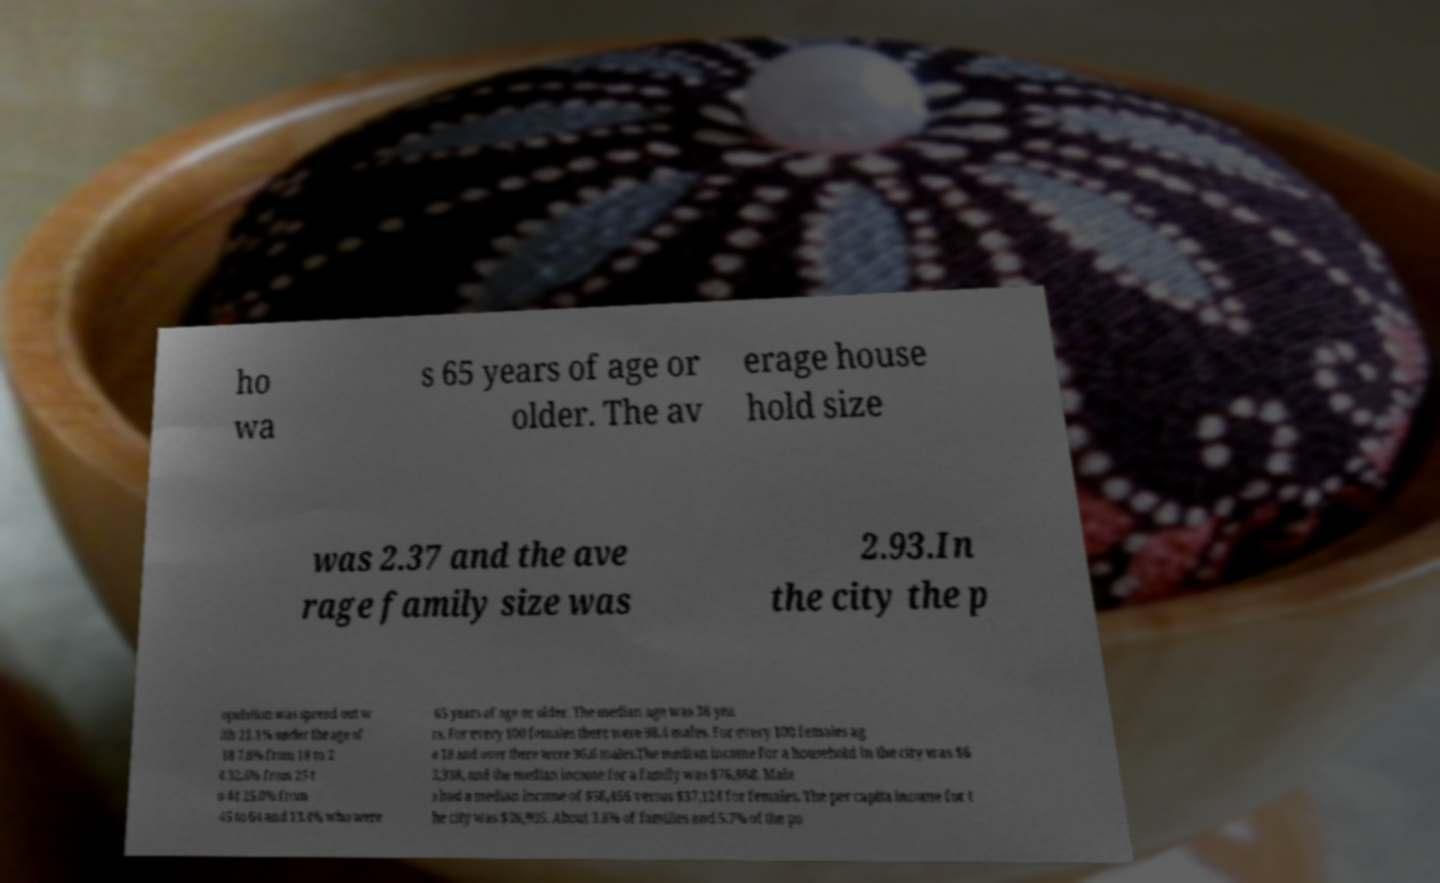Could you assist in decoding the text presented in this image and type it out clearly? ho wa s 65 years of age or older. The av erage house hold size was 2.37 and the ave rage family size was 2.93.In the city the p opulation was spread out w ith 21.1% under the age of 18 7.8% from 18 to 2 4 32.6% from 25 t o 44 25.0% from 45 to 64 and 13.4% who were 65 years of age or older. The median age was 38 yea rs. For every 100 females there were 98.4 males. For every 100 females ag e 18 and over there were 96.6 males.The median income for a household in the city was $6 2,338, and the median income for a family was $76,868. Male s had a median income of $56,456 versus $37,124 for females. The per capita income for t he city was $36,905. About 3.8% of families and 5.7% of the po 